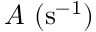<formula> <loc_0><loc_0><loc_500><loc_500>A ( s ^ { - 1 } )</formula> 